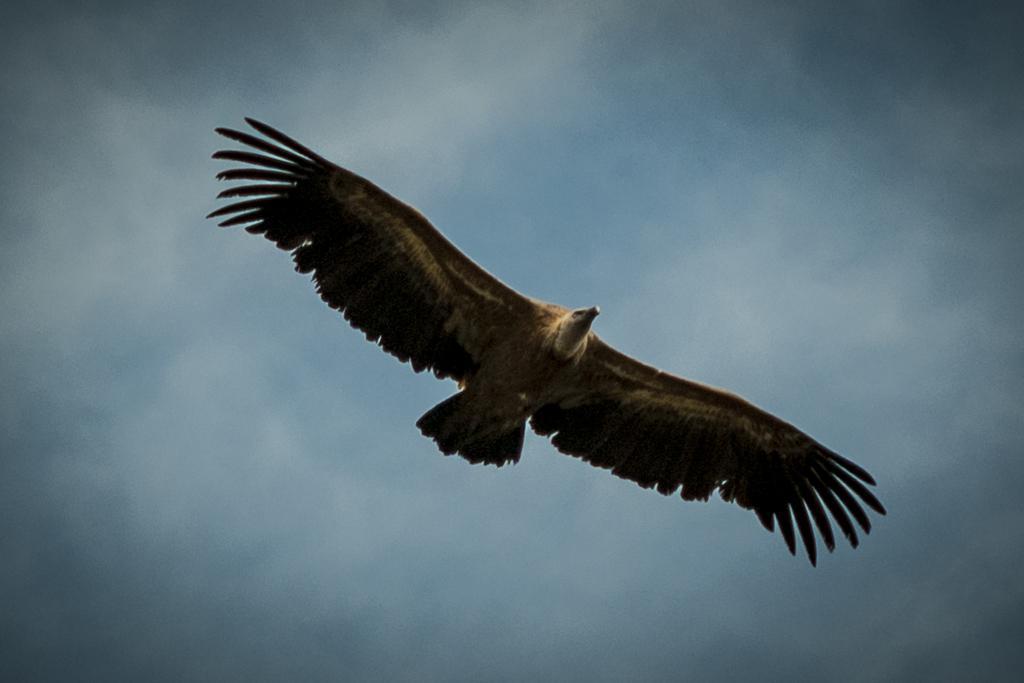Please provide a concise description of this image. In the picture I can see an eagle flying in the air and the sky is cloudy. 